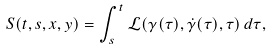<formula> <loc_0><loc_0><loc_500><loc_500>S ( t , s , x , y ) = \int _ { s } ^ { t } \mathcal { L } ( \gamma ( \tau ) , \dot { \gamma } ( \tau ) , \tau ) \, d \tau ,</formula> 